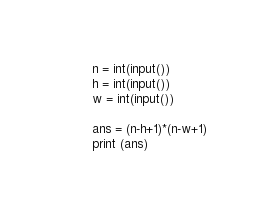<code> <loc_0><loc_0><loc_500><loc_500><_Python_>n = int(input())
h = int(input())
w = int(input())

ans = (n-h+1)*(n-w+1)
print (ans)</code> 